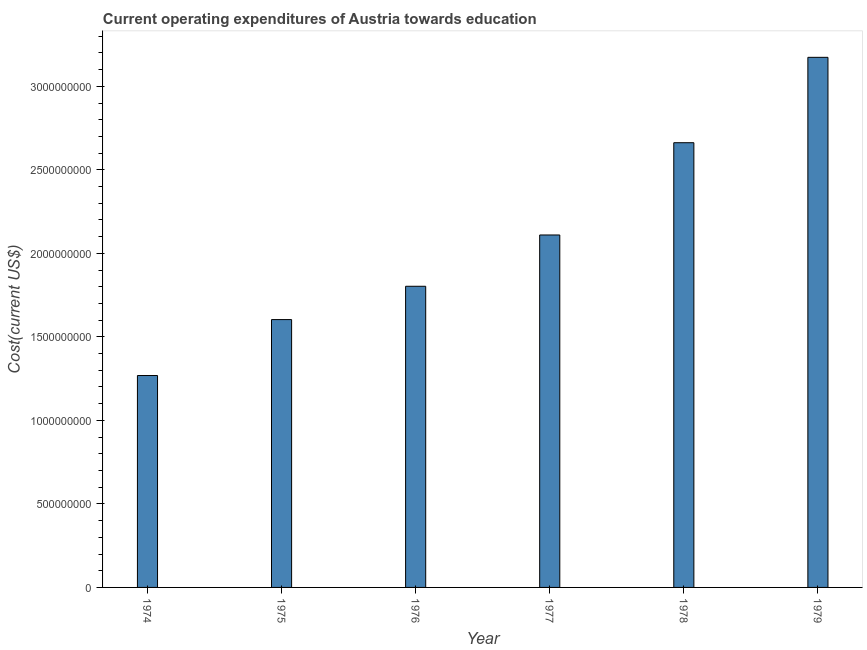What is the title of the graph?
Your answer should be compact. Current operating expenditures of Austria towards education. What is the label or title of the Y-axis?
Keep it short and to the point. Cost(current US$). What is the education expenditure in 1975?
Your response must be concise. 1.60e+09. Across all years, what is the maximum education expenditure?
Your response must be concise. 3.17e+09. Across all years, what is the minimum education expenditure?
Give a very brief answer. 1.27e+09. In which year was the education expenditure maximum?
Your response must be concise. 1979. In which year was the education expenditure minimum?
Make the answer very short. 1974. What is the sum of the education expenditure?
Ensure brevity in your answer.  1.26e+1. What is the difference between the education expenditure in 1974 and 1977?
Your response must be concise. -8.41e+08. What is the average education expenditure per year?
Keep it short and to the point. 2.10e+09. What is the median education expenditure?
Provide a short and direct response. 1.96e+09. In how many years, is the education expenditure greater than 900000000 US$?
Provide a short and direct response. 6. What is the ratio of the education expenditure in 1975 to that in 1978?
Offer a very short reply. 0.6. Is the difference between the education expenditure in 1976 and 1978 greater than the difference between any two years?
Your response must be concise. No. What is the difference between the highest and the second highest education expenditure?
Provide a succinct answer. 5.11e+08. Is the sum of the education expenditure in 1975 and 1979 greater than the maximum education expenditure across all years?
Offer a terse response. Yes. What is the difference between the highest and the lowest education expenditure?
Keep it short and to the point. 1.90e+09. In how many years, is the education expenditure greater than the average education expenditure taken over all years?
Provide a short and direct response. 3. How many years are there in the graph?
Give a very brief answer. 6. What is the difference between two consecutive major ticks on the Y-axis?
Ensure brevity in your answer.  5.00e+08. Are the values on the major ticks of Y-axis written in scientific E-notation?
Keep it short and to the point. No. What is the Cost(current US$) of 1974?
Offer a terse response. 1.27e+09. What is the Cost(current US$) of 1975?
Provide a succinct answer. 1.60e+09. What is the Cost(current US$) in 1976?
Your answer should be compact. 1.80e+09. What is the Cost(current US$) of 1977?
Your answer should be very brief. 2.11e+09. What is the Cost(current US$) of 1978?
Make the answer very short. 2.66e+09. What is the Cost(current US$) in 1979?
Your answer should be compact. 3.17e+09. What is the difference between the Cost(current US$) in 1974 and 1975?
Ensure brevity in your answer.  -3.35e+08. What is the difference between the Cost(current US$) in 1974 and 1976?
Your answer should be very brief. -5.34e+08. What is the difference between the Cost(current US$) in 1974 and 1977?
Keep it short and to the point. -8.41e+08. What is the difference between the Cost(current US$) in 1974 and 1978?
Your answer should be very brief. -1.39e+09. What is the difference between the Cost(current US$) in 1974 and 1979?
Provide a succinct answer. -1.90e+09. What is the difference between the Cost(current US$) in 1975 and 1976?
Your response must be concise. -1.99e+08. What is the difference between the Cost(current US$) in 1975 and 1977?
Ensure brevity in your answer.  -5.07e+08. What is the difference between the Cost(current US$) in 1975 and 1978?
Your response must be concise. -1.06e+09. What is the difference between the Cost(current US$) in 1975 and 1979?
Give a very brief answer. -1.57e+09. What is the difference between the Cost(current US$) in 1976 and 1977?
Your answer should be compact. -3.07e+08. What is the difference between the Cost(current US$) in 1976 and 1978?
Ensure brevity in your answer.  -8.59e+08. What is the difference between the Cost(current US$) in 1976 and 1979?
Provide a succinct answer. -1.37e+09. What is the difference between the Cost(current US$) in 1977 and 1978?
Give a very brief answer. -5.52e+08. What is the difference between the Cost(current US$) in 1977 and 1979?
Keep it short and to the point. -1.06e+09. What is the difference between the Cost(current US$) in 1978 and 1979?
Provide a short and direct response. -5.11e+08. What is the ratio of the Cost(current US$) in 1974 to that in 1975?
Your answer should be very brief. 0.79. What is the ratio of the Cost(current US$) in 1974 to that in 1976?
Make the answer very short. 0.7. What is the ratio of the Cost(current US$) in 1974 to that in 1977?
Give a very brief answer. 0.6. What is the ratio of the Cost(current US$) in 1974 to that in 1978?
Your answer should be compact. 0.48. What is the ratio of the Cost(current US$) in 1975 to that in 1976?
Your response must be concise. 0.89. What is the ratio of the Cost(current US$) in 1975 to that in 1977?
Offer a very short reply. 0.76. What is the ratio of the Cost(current US$) in 1975 to that in 1978?
Give a very brief answer. 0.6. What is the ratio of the Cost(current US$) in 1975 to that in 1979?
Give a very brief answer. 0.51. What is the ratio of the Cost(current US$) in 1976 to that in 1977?
Offer a very short reply. 0.85. What is the ratio of the Cost(current US$) in 1976 to that in 1978?
Make the answer very short. 0.68. What is the ratio of the Cost(current US$) in 1976 to that in 1979?
Make the answer very short. 0.57. What is the ratio of the Cost(current US$) in 1977 to that in 1978?
Offer a terse response. 0.79. What is the ratio of the Cost(current US$) in 1977 to that in 1979?
Offer a very short reply. 0.67. What is the ratio of the Cost(current US$) in 1978 to that in 1979?
Your answer should be very brief. 0.84. 